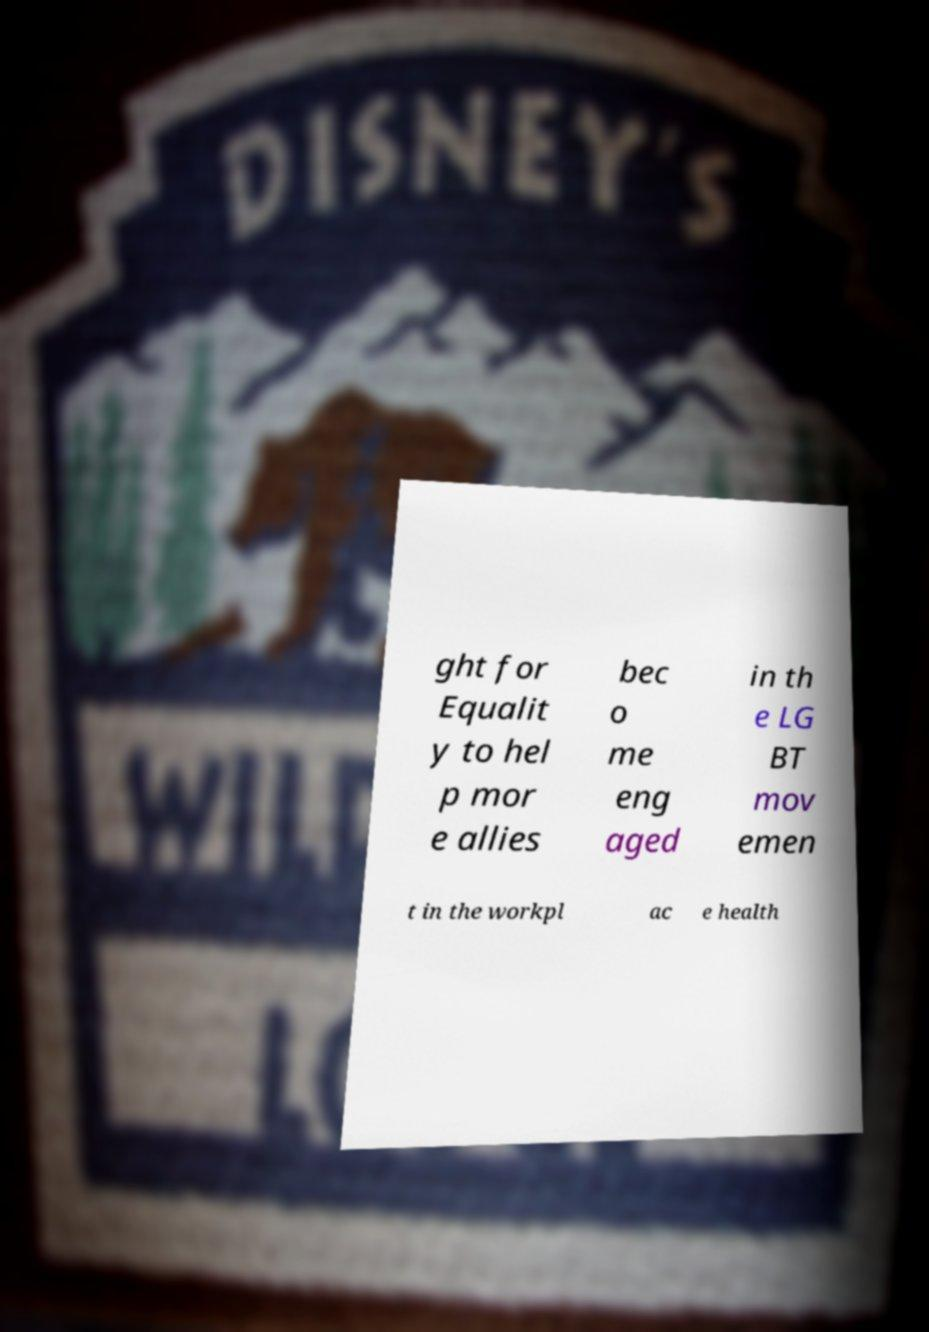Can you accurately transcribe the text from the provided image for me? ght for Equalit y to hel p mor e allies bec o me eng aged in th e LG BT mov emen t in the workpl ac e health 